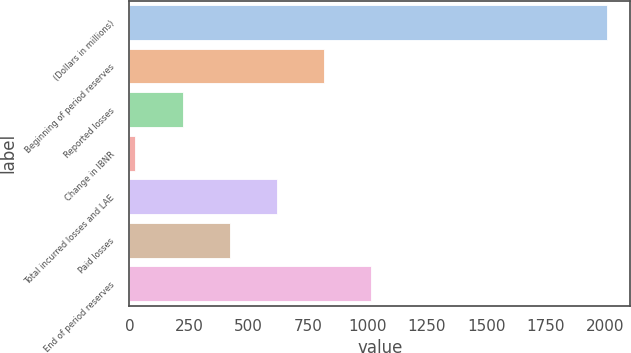Convert chart. <chart><loc_0><loc_0><loc_500><loc_500><bar_chart><fcel>(Dollars in millions)<fcel>Beginning of period reserves<fcel>Reported losses<fcel>Change in IBNR<fcel>Total incurred losses and LAE<fcel>Paid losses<fcel>End of period reserves<nl><fcel>2006<fcel>817.7<fcel>223.55<fcel>25.5<fcel>619.65<fcel>421.6<fcel>1015.75<nl></chart> 